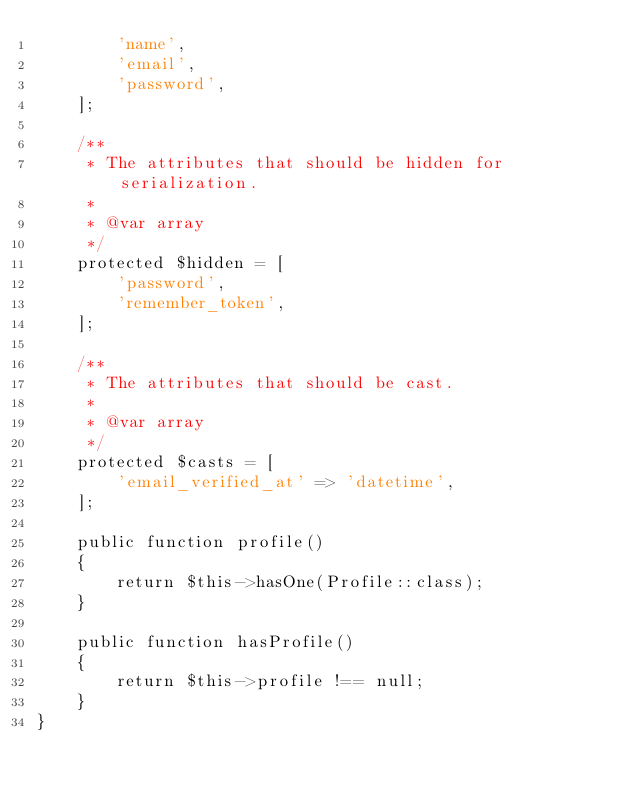Convert code to text. <code><loc_0><loc_0><loc_500><loc_500><_PHP_>        'name',
        'email',
        'password',
    ];

    /**
     * The attributes that should be hidden for serialization.
     *
     * @var array
     */
    protected $hidden = [
        'password',
        'remember_token',
    ];

    /**
     * The attributes that should be cast.
     *
     * @var array
     */
    protected $casts = [
        'email_verified_at' => 'datetime',
    ];

    public function profile()
    {
        return $this->hasOne(Profile::class);
    }

    public function hasProfile()
    {
        return $this->profile !== null;
    }
}
</code> 